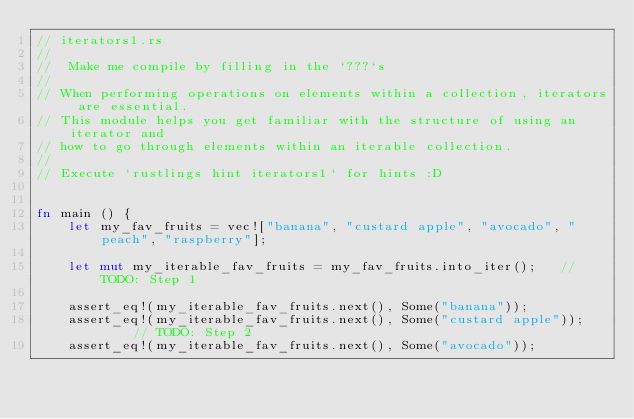<code> <loc_0><loc_0><loc_500><loc_500><_Rust_>// iterators1.rs
// 
//  Make me compile by filling in the `???`s
//
// When performing operations on elements within a collection, iterators are essential.
// This module helps you get familiar with the structure of using an iterator and 
// how to go through elements within an iterable collection.
// 
// Execute `rustlings hint iterators1` for hints :D


fn main () {
    let my_fav_fruits = vec!["banana", "custard apple", "avocado", "peach", "raspberry"];

    let mut my_iterable_fav_fruits = my_fav_fruits.into_iter();   // TODO: Step 1

    assert_eq!(my_iterable_fav_fruits.next(), Some("banana"));
    assert_eq!(my_iterable_fav_fruits.next(), Some("custard apple"));     // TODO: Step 2
    assert_eq!(my_iterable_fav_fruits.next(), Some("avocado"));</code> 